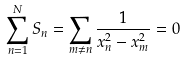Convert formula to latex. <formula><loc_0><loc_0><loc_500><loc_500>\sum _ { n = 1 } ^ { N } S _ { n } = \sum _ { m \ne n } \frac { 1 } { x _ { n } ^ { 2 } - x _ { m } ^ { 2 } } = 0</formula> 